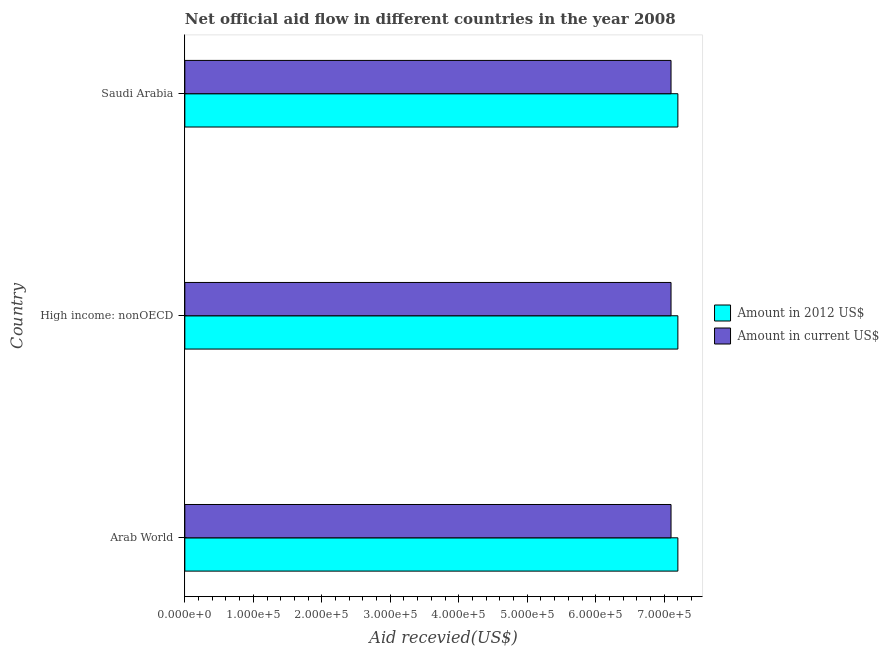How many different coloured bars are there?
Provide a short and direct response. 2. How many groups of bars are there?
Your response must be concise. 3. Are the number of bars per tick equal to the number of legend labels?
Provide a succinct answer. Yes. Are the number of bars on each tick of the Y-axis equal?
Offer a terse response. Yes. How many bars are there on the 3rd tick from the bottom?
Give a very brief answer. 2. What is the label of the 1st group of bars from the top?
Your response must be concise. Saudi Arabia. In how many cases, is the number of bars for a given country not equal to the number of legend labels?
Ensure brevity in your answer.  0. What is the amount of aid received(expressed in us$) in High income: nonOECD?
Keep it short and to the point. 7.10e+05. Across all countries, what is the maximum amount of aid received(expressed in us$)?
Offer a terse response. 7.10e+05. Across all countries, what is the minimum amount of aid received(expressed in us$)?
Make the answer very short. 7.10e+05. In which country was the amount of aid received(expressed in 2012 us$) maximum?
Make the answer very short. Arab World. In which country was the amount of aid received(expressed in us$) minimum?
Your answer should be very brief. Arab World. What is the total amount of aid received(expressed in us$) in the graph?
Provide a succinct answer. 2.13e+06. What is the difference between the amount of aid received(expressed in 2012 us$) in Arab World and the amount of aid received(expressed in us$) in Saudi Arabia?
Keep it short and to the point. 10000. What is the average amount of aid received(expressed in us$) per country?
Offer a very short reply. 7.10e+05. What is the difference between the amount of aid received(expressed in us$) and amount of aid received(expressed in 2012 us$) in Arab World?
Your answer should be compact. -10000. In how many countries, is the amount of aid received(expressed in us$) greater than 20000 US$?
Offer a terse response. 3. What is the ratio of the amount of aid received(expressed in 2012 us$) in Arab World to that in High income: nonOECD?
Your answer should be compact. 1. What is the difference between the highest and the second highest amount of aid received(expressed in us$)?
Your response must be concise. 0. In how many countries, is the amount of aid received(expressed in us$) greater than the average amount of aid received(expressed in us$) taken over all countries?
Give a very brief answer. 0. Is the sum of the amount of aid received(expressed in us$) in High income: nonOECD and Saudi Arabia greater than the maximum amount of aid received(expressed in 2012 us$) across all countries?
Provide a short and direct response. Yes. What does the 1st bar from the top in High income: nonOECD represents?
Provide a succinct answer. Amount in current US$. What does the 2nd bar from the bottom in High income: nonOECD represents?
Provide a short and direct response. Amount in current US$. How many bars are there?
Keep it short and to the point. 6. How many countries are there in the graph?
Make the answer very short. 3. What is the difference between two consecutive major ticks on the X-axis?
Offer a terse response. 1.00e+05. Are the values on the major ticks of X-axis written in scientific E-notation?
Your answer should be very brief. Yes. Does the graph contain any zero values?
Your response must be concise. No. Does the graph contain grids?
Give a very brief answer. No. Where does the legend appear in the graph?
Offer a terse response. Center right. What is the title of the graph?
Keep it short and to the point. Net official aid flow in different countries in the year 2008. What is the label or title of the X-axis?
Your answer should be very brief. Aid recevied(US$). What is the Aid recevied(US$) of Amount in 2012 US$ in Arab World?
Provide a succinct answer. 7.20e+05. What is the Aid recevied(US$) of Amount in current US$ in Arab World?
Offer a very short reply. 7.10e+05. What is the Aid recevied(US$) in Amount in 2012 US$ in High income: nonOECD?
Offer a very short reply. 7.20e+05. What is the Aid recevied(US$) of Amount in current US$ in High income: nonOECD?
Give a very brief answer. 7.10e+05. What is the Aid recevied(US$) in Amount in 2012 US$ in Saudi Arabia?
Your response must be concise. 7.20e+05. What is the Aid recevied(US$) of Amount in current US$ in Saudi Arabia?
Your response must be concise. 7.10e+05. Across all countries, what is the maximum Aid recevied(US$) of Amount in 2012 US$?
Offer a terse response. 7.20e+05. Across all countries, what is the maximum Aid recevied(US$) in Amount in current US$?
Provide a short and direct response. 7.10e+05. Across all countries, what is the minimum Aid recevied(US$) of Amount in 2012 US$?
Give a very brief answer. 7.20e+05. Across all countries, what is the minimum Aid recevied(US$) in Amount in current US$?
Your answer should be very brief. 7.10e+05. What is the total Aid recevied(US$) of Amount in 2012 US$ in the graph?
Ensure brevity in your answer.  2.16e+06. What is the total Aid recevied(US$) in Amount in current US$ in the graph?
Give a very brief answer. 2.13e+06. What is the difference between the Aid recevied(US$) in Amount in current US$ in High income: nonOECD and that in Saudi Arabia?
Give a very brief answer. 0. What is the difference between the Aid recevied(US$) in Amount in 2012 US$ in Arab World and the Aid recevied(US$) in Amount in current US$ in High income: nonOECD?
Make the answer very short. 10000. What is the difference between the Aid recevied(US$) of Amount in 2012 US$ in Arab World and the Aid recevied(US$) of Amount in current US$ in Saudi Arabia?
Your answer should be very brief. 10000. What is the average Aid recevied(US$) in Amount in 2012 US$ per country?
Make the answer very short. 7.20e+05. What is the average Aid recevied(US$) in Amount in current US$ per country?
Your response must be concise. 7.10e+05. What is the difference between the Aid recevied(US$) in Amount in 2012 US$ and Aid recevied(US$) in Amount in current US$ in High income: nonOECD?
Offer a terse response. 10000. What is the ratio of the Aid recevied(US$) in Amount in 2012 US$ in Arab World to that in High income: nonOECD?
Your answer should be very brief. 1. What is the ratio of the Aid recevied(US$) in Amount in current US$ in Arab World to that in High income: nonOECD?
Keep it short and to the point. 1. What is the ratio of the Aid recevied(US$) in Amount in 2012 US$ in Arab World to that in Saudi Arabia?
Keep it short and to the point. 1. What is the ratio of the Aid recevied(US$) in Amount in current US$ in High income: nonOECD to that in Saudi Arabia?
Provide a succinct answer. 1. What is the difference between the highest and the second highest Aid recevied(US$) of Amount in 2012 US$?
Offer a very short reply. 0. What is the difference between the highest and the lowest Aid recevied(US$) in Amount in 2012 US$?
Ensure brevity in your answer.  0. 